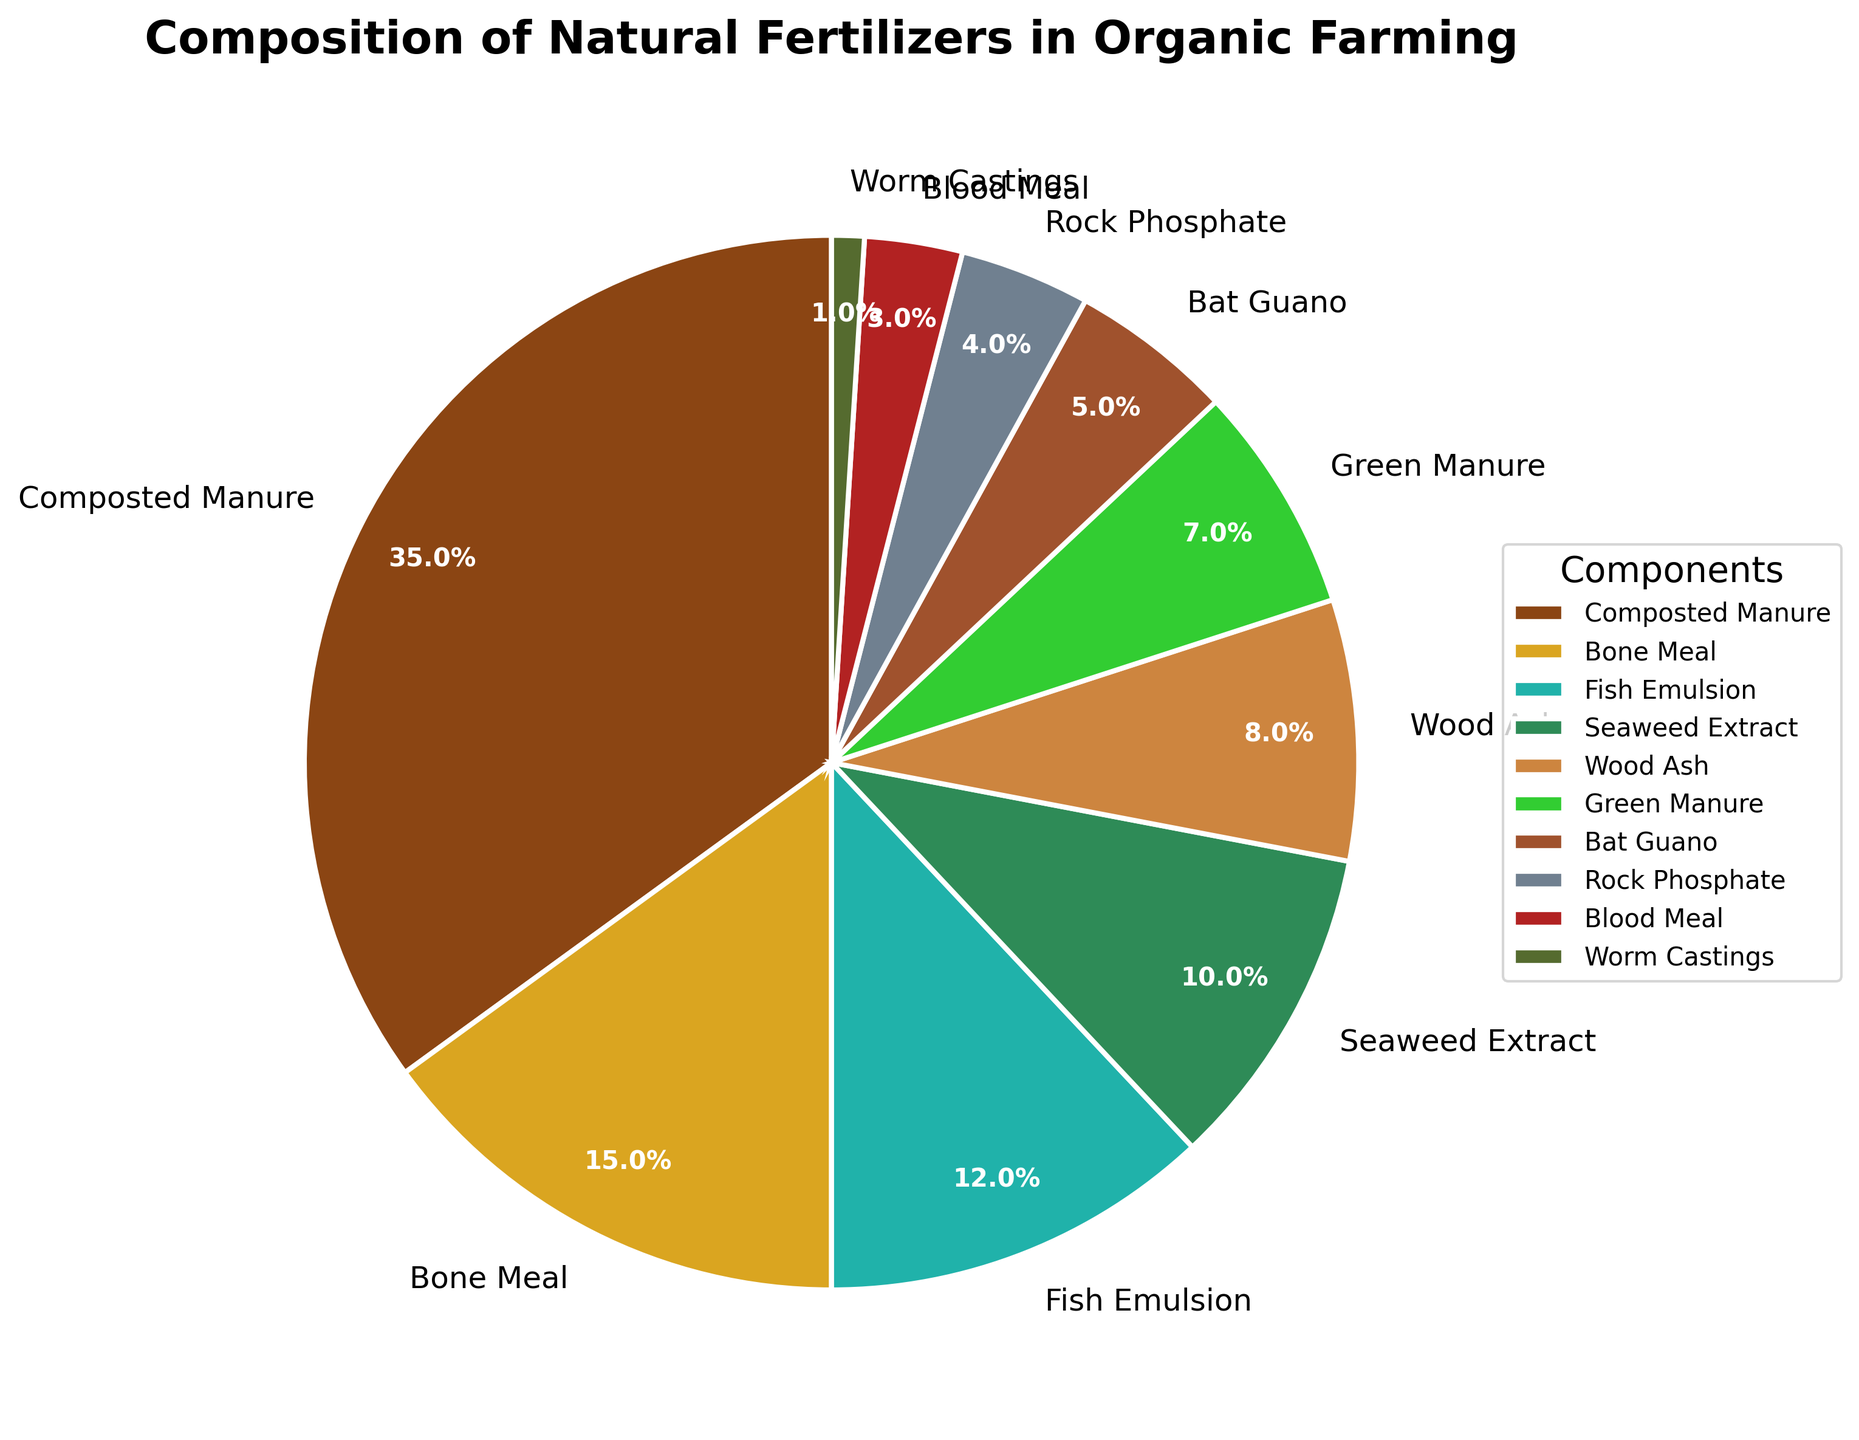Who contributed the highest percentage of the natural fertilizers? Looking at the pie chart, the segment with the largest percentage is labeled, indicating it represents Composted Manure with 35%.
Answer: Composted Manure Which component has the smallest contribution to the natural fertilizers? The smallest segment in the pie chart, labeled with 1%, is Worm Castings.
Answer: Worm Castings What's the combined percentage of Bone Meal and Fish Emulsion? Bone Meal is 15% and Fish Emulsion is 12%. Adding these together: 15% + 12% = 27%.
Answer: 27% Is the percentage contribution of Seaweed Extract greater than that of Wood Ash? Seaweed Extract contributes 10%, whereas Wood Ash contributes 8%. 10% is greater than 8%.
Answer: Yes How much greater is the percentage of Composted Manure compared to Bat Guano? Composted Manure is 35% and Bat Guano is 5%. Subtracting these: 35% - 5% = 30%.
Answer: 30% Which components together account for over 50% of the natural fertilizers? Composted Manure is 35%, Bone Meal is 15%, together they make 50%. Adding any other percentage would make it over 50%, but these two alone already do.
Answer: Composted Manure and Bone Meal Are the combined contributions of Rock Phosphate and Blood Meal equal to or greater than Green Manure? Rock Phosphate is 4%, Blood Meal is 3%, and Green Manure is 7%. 4% + 3% = 7%, which is equal to Green Manure's contribution.
Answer: Equal What is the total percentage contributed by components less than 10%? Summing up percentages under 10%: Rock Phosphate (4%) + Blood Meal (3%) + Worm Castings (1%) + Bat Guano (5%) + Green Manure (7%) + Wood Ash (8%) = 28%.
Answer: 28% Which has a larger contribution, Fish Emulsion or Seaweed Extract? Fish Emulsion is 12% and Seaweed Extract is 10%. 12% is larger than 10%.
Answer: Fish Emulsion 